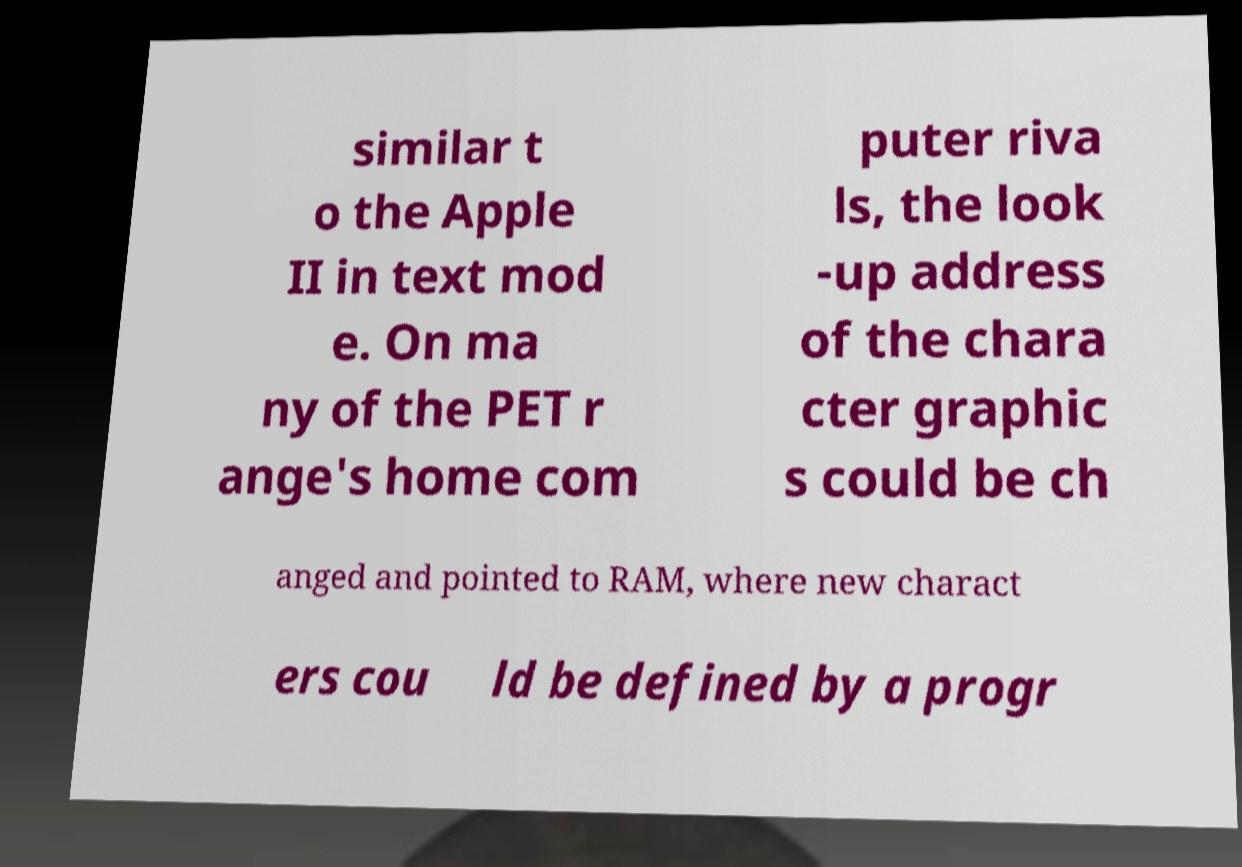Please identify and transcribe the text found in this image. similar t o the Apple II in text mod e. On ma ny of the PET r ange's home com puter riva ls, the look -up address of the chara cter graphic s could be ch anged and pointed to RAM, where new charact ers cou ld be defined by a progr 